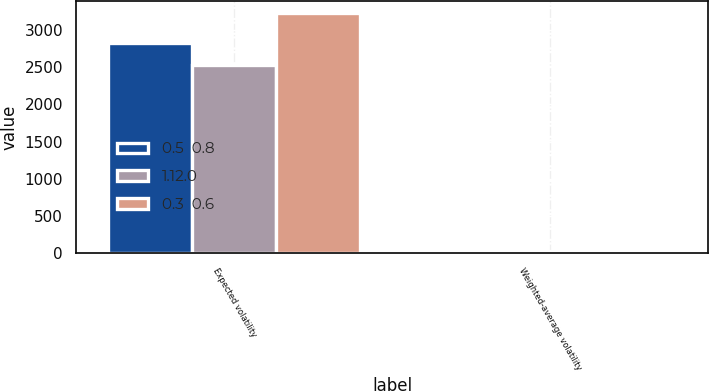Convert chart to OTSL. <chart><loc_0><loc_0><loc_500><loc_500><stacked_bar_chart><ecel><fcel>Expected volatility<fcel>Weighted-average volatility<nl><fcel>0.5  0.8<fcel>2830<fcel>29<nl><fcel>1.12.0<fcel>2532<fcel>27<nl><fcel>0.3  0.6<fcel>3236<fcel>33<nl></chart> 